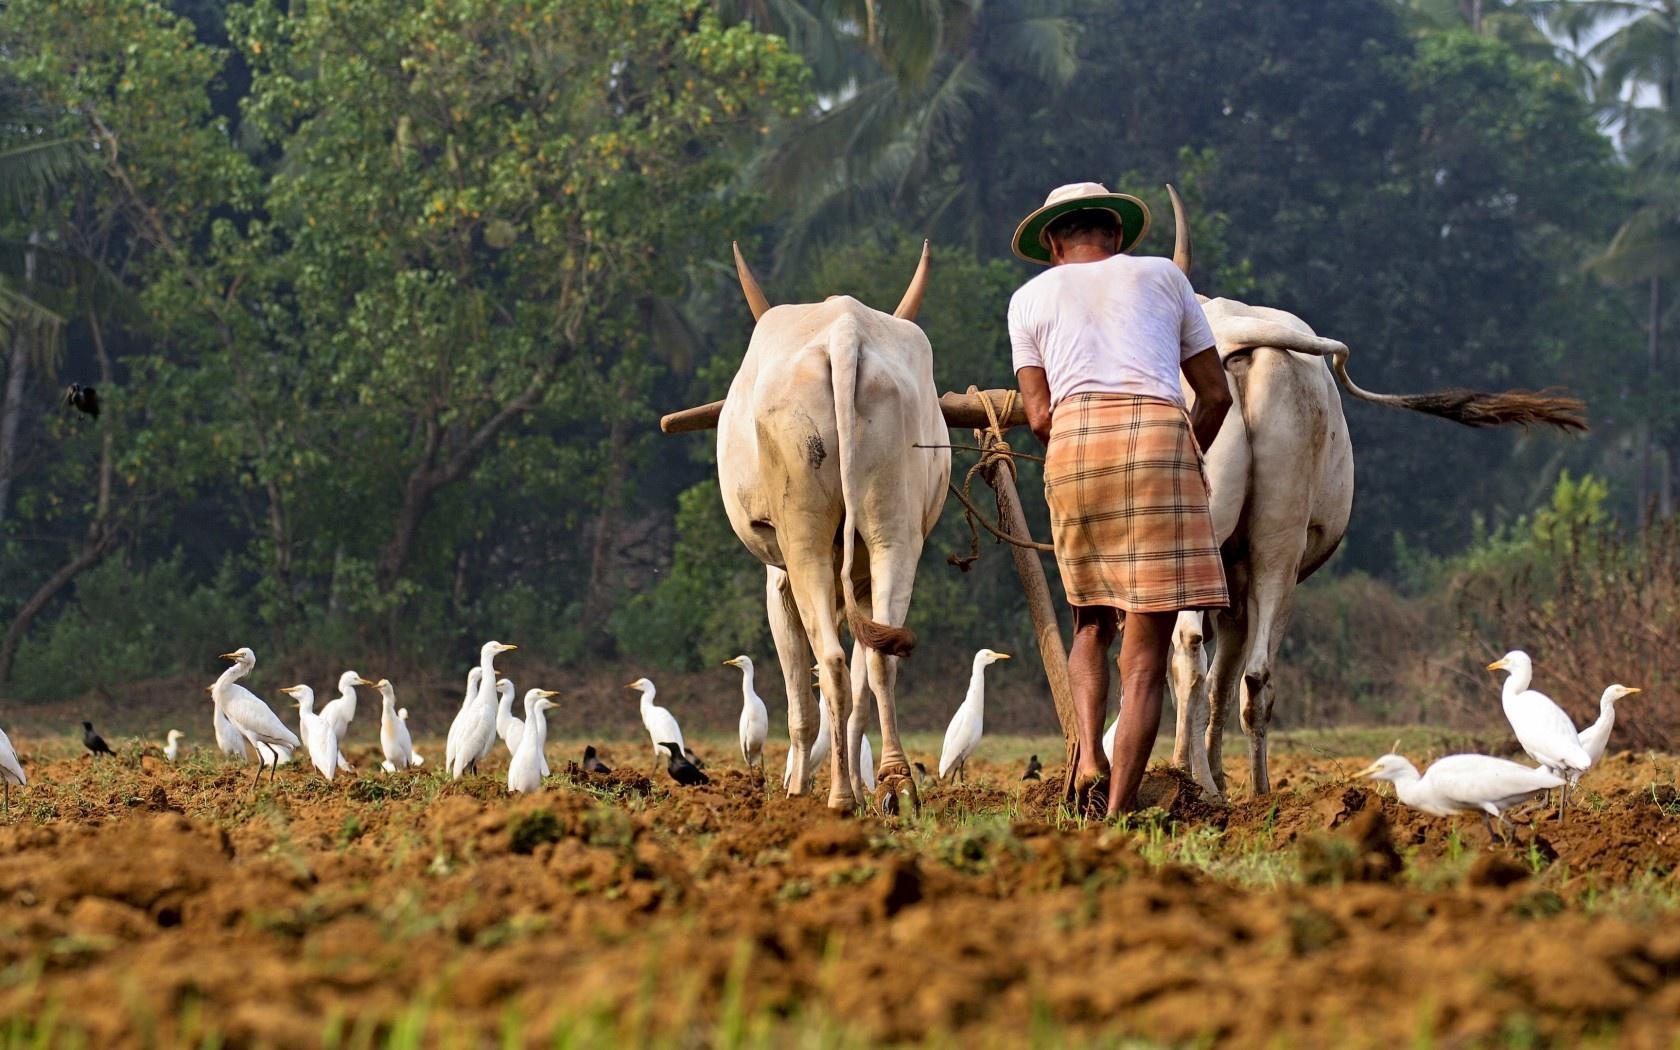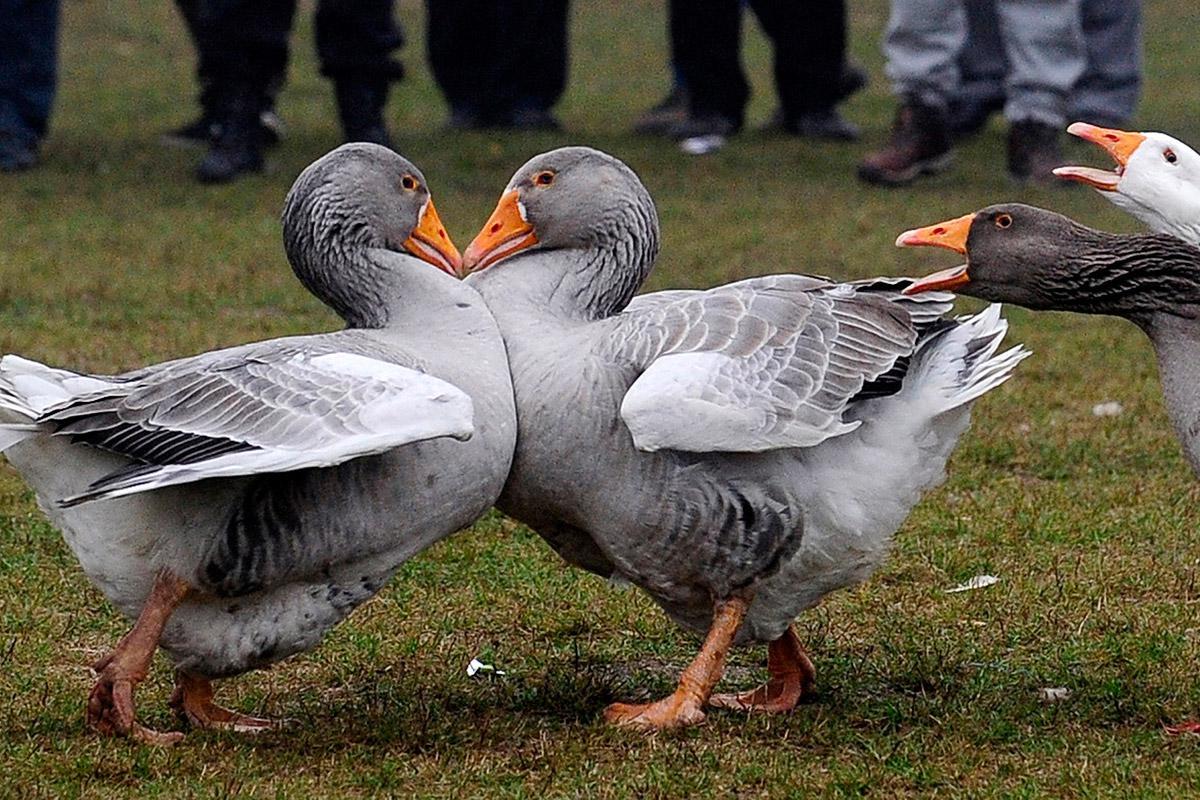The first image is the image on the left, the second image is the image on the right. Assess this claim about the two images: "A single woman is standing with birds in the image on the left.". Correct or not? Answer yes or no. Yes. The first image is the image on the left, the second image is the image on the right. Given the left and right images, does the statement "One image shows a dog standing on grass behind a small flock of duck-like birds." hold true? Answer yes or no. No. 